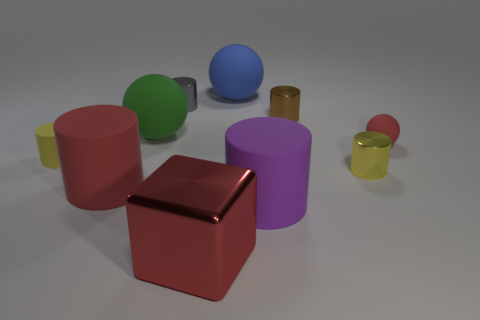Is the material of the tiny yellow object that is to the left of the gray cylinder the same as the red sphere?
Provide a succinct answer. Yes. Is the number of metal cylinders that are to the left of the yellow metallic cylinder less than the number of yellow rubber cylinders?
Offer a terse response. No. Is there a thing made of the same material as the big red block?
Ensure brevity in your answer.  Yes. There is a yellow rubber thing; is it the same size as the yellow cylinder to the right of the big green matte thing?
Ensure brevity in your answer.  Yes. Is there a large rubber cylinder of the same color as the block?
Your answer should be compact. Yes. Does the brown object have the same material as the purple object?
Your answer should be very brief. No. How many yellow shiny cylinders are left of the large blue rubber sphere?
Offer a very short reply. 0. There is a big thing that is in front of the green thing and behind the large purple thing; what is it made of?
Offer a terse response. Rubber. How many green rubber balls are the same size as the red rubber sphere?
Your answer should be very brief. 0. The tiny rubber thing right of the tiny yellow object that is on the right side of the big red cylinder is what color?
Your response must be concise. Red. 